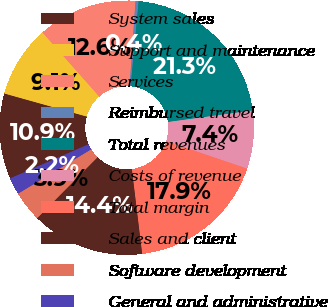Convert chart to OTSL. <chart><loc_0><loc_0><loc_500><loc_500><pie_chart><fcel>System sales<fcel>Support and maintenance<fcel>Services<fcel>Reimbursed travel<fcel>Total revenues<fcel>Costs of revenue<fcel>Total margin<fcel>Sales and client<fcel>Software development<fcel>General and administrative<nl><fcel>10.87%<fcel>9.13%<fcel>12.62%<fcel>0.4%<fcel>21.34%<fcel>7.38%<fcel>17.85%<fcel>14.36%<fcel>3.89%<fcel>2.15%<nl></chart> 